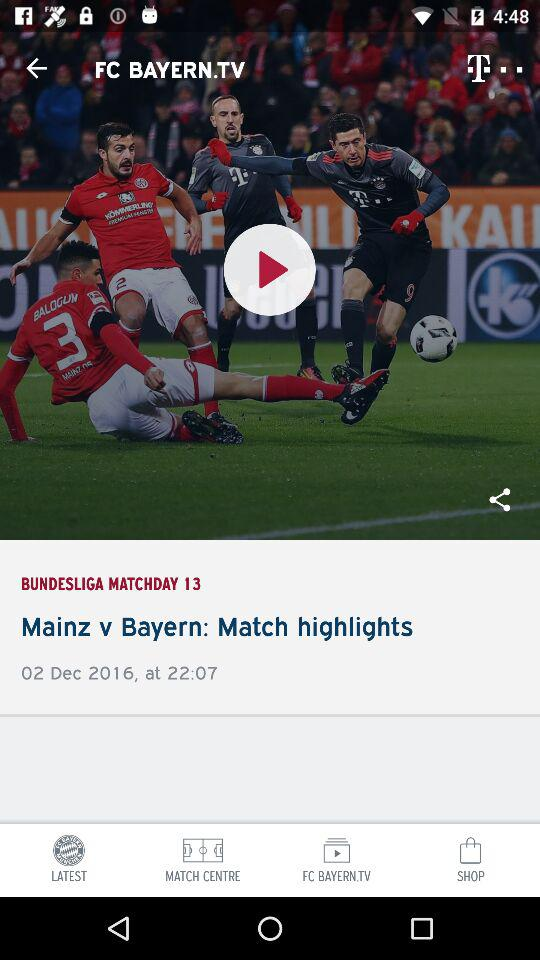What are the two teams? The teams are "Mainz" and "Bayern". 